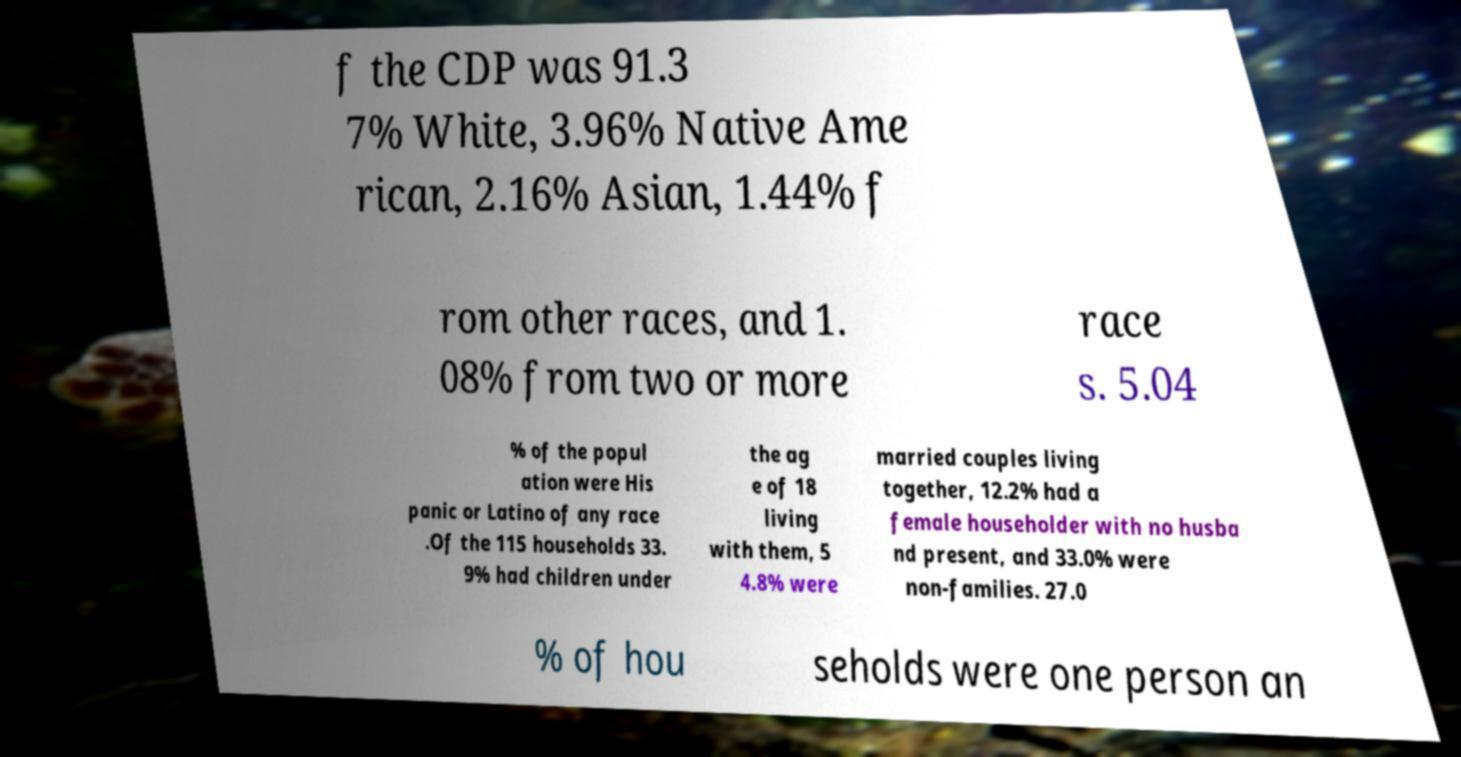Could you extract and type out the text from this image? f the CDP was 91.3 7% White, 3.96% Native Ame rican, 2.16% Asian, 1.44% f rom other races, and 1. 08% from two or more race s. 5.04 % of the popul ation were His panic or Latino of any race .Of the 115 households 33. 9% had children under the ag e of 18 living with them, 5 4.8% were married couples living together, 12.2% had a female householder with no husba nd present, and 33.0% were non-families. 27.0 % of hou seholds were one person an 